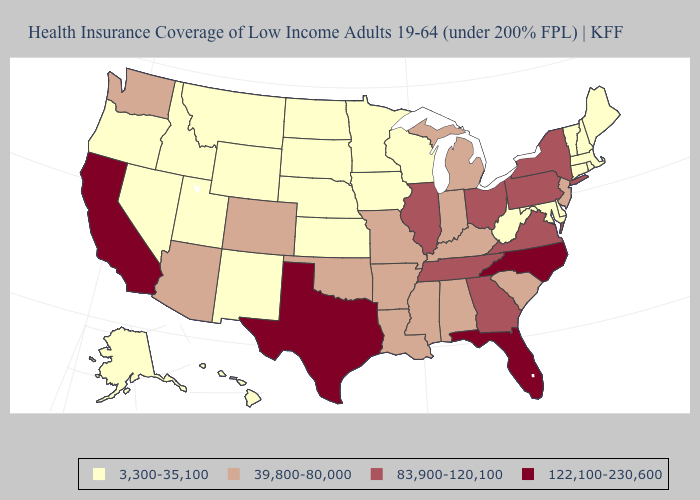Which states hav the highest value in the MidWest?
Short answer required. Illinois, Ohio. Which states have the lowest value in the USA?
Be succinct. Alaska, Connecticut, Delaware, Hawaii, Idaho, Iowa, Kansas, Maine, Maryland, Massachusetts, Minnesota, Montana, Nebraska, Nevada, New Hampshire, New Mexico, North Dakota, Oregon, Rhode Island, South Dakota, Utah, Vermont, West Virginia, Wisconsin, Wyoming. Name the states that have a value in the range 39,800-80,000?
Keep it brief. Alabama, Arizona, Arkansas, Colorado, Indiana, Kentucky, Louisiana, Michigan, Mississippi, Missouri, New Jersey, Oklahoma, South Carolina, Washington. Name the states that have a value in the range 83,900-120,100?
Short answer required. Georgia, Illinois, New York, Ohio, Pennsylvania, Tennessee, Virginia. What is the value of Pennsylvania?
Short answer required. 83,900-120,100. Is the legend a continuous bar?
Write a very short answer. No. Does Florida have the same value as New Jersey?
Keep it brief. No. Among the states that border Iowa , does Minnesota have the highest value?
Be succinct. No. Does Texas have the highest value in the USA?
Concise answer only. Yes. What is the highest value in the USA?
Concise answer only. 122,100-230,600. Does California have the lowest value in the West?
Give a very brief answer. No. Among the states that border Michigan , does Indiana have the highest value?
Give a very brief answer. No. Which states have the lowest value in the USA?
Write a very short answer. Alaska, Connecticut, Delaware, Hawaii, Idaho, Iowa, Kansas, Maine, Maryland, Massachusetts, Minnesota, Montana, Nebraska, Nevada, New Hampshire, New Mexico, North Dakota, Oregon, Rhode Island, South Dakota, Utah, Vermont, West Virginia, Wisconsin, Wyoming. Does Texas have the highest value in the USA?
Keep it brief. Yes. Does Illinois have the highest value in the MidWest?
Quick response, please. Yes. 